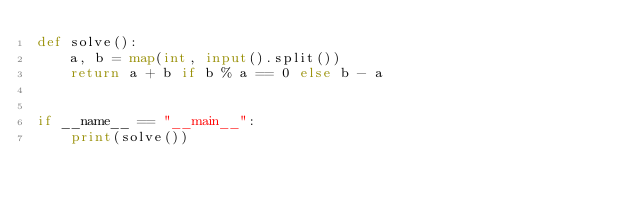Convert code to text. <code><loc_0><loc_0><loc_500><loc_500><_Python_>def solve():
    a, b = map(int, input().split())
    return a + b if b % a == 0 else b - a


if __name__ == "__main__":
    print(solve())
</code> 